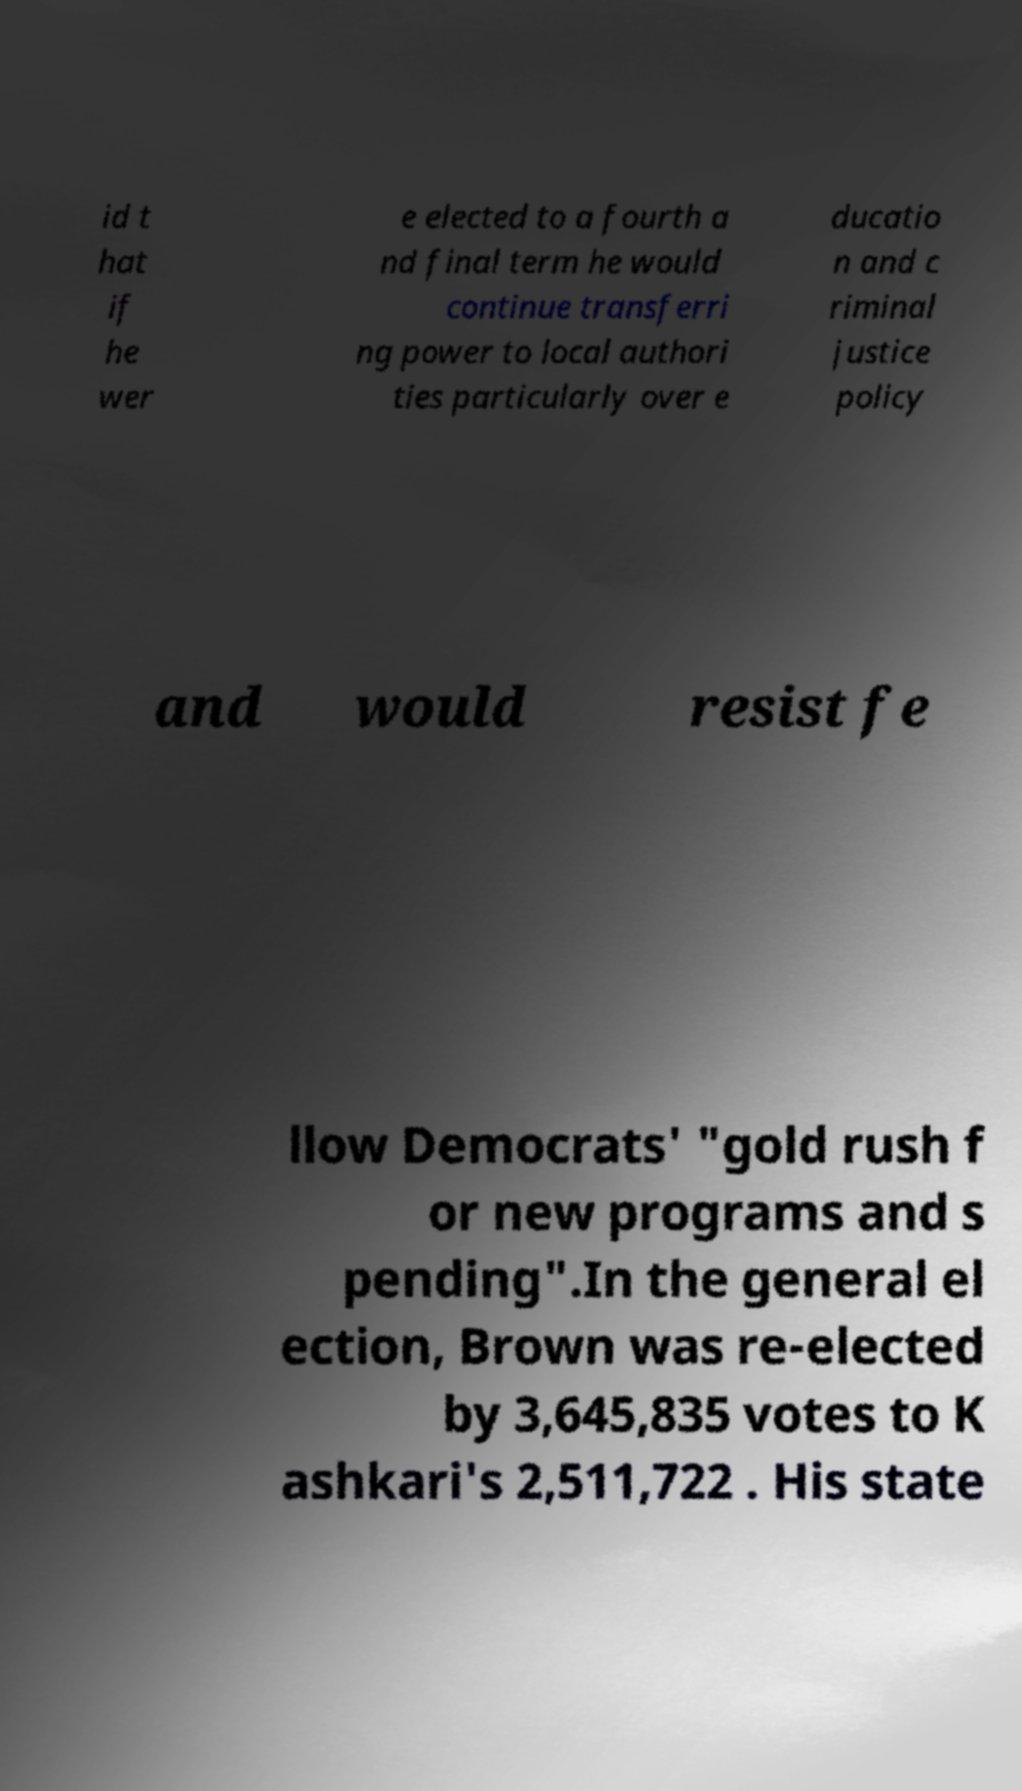For documentation purposes, I need the text within this image transcribed. Could you provide that? id t hat if he wer e elected to a fourth a nd final term he would continue transferri ng power to local authori ties particularly over e ducatio n and c riminal justice policy and would resist fe llow Democrats' "gold rush f or new programs and s pending".In the general el ection, Brown was re-elected by 3,645,835 votes to K ashkari's 2,511,722 . His state 